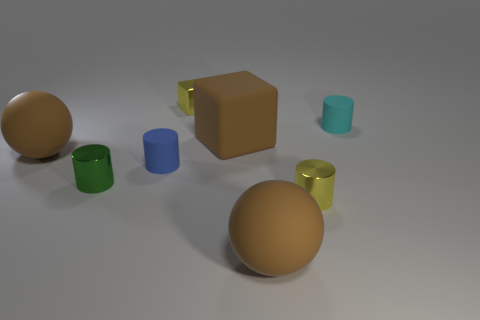Subtract all tiny cyan cylinders. How many cylinders are left? 3 Add 1 matte cubes. How many objects exist? 9 Subtract all yellow cylinders. How many cylinders are left? 3 Subtract 1 cylinders. How many cylinders are left? 3 Subtract all spheres. How many objects are left? 6 Add 5 tiny shiny blocks. How many tiny shiny blocks are left? 6 Add 4 big brown spheres. How many big brown spheres exist? 6 Subtract 1 brown blocks. How many objects are left? 7 Subtract all cyan blocks. Subtract all brown cylinders. How many blocks are left? 2 Subtract all big brown rubber spheres. Subtract all tiny blue matte things. How many objects are left? 5 